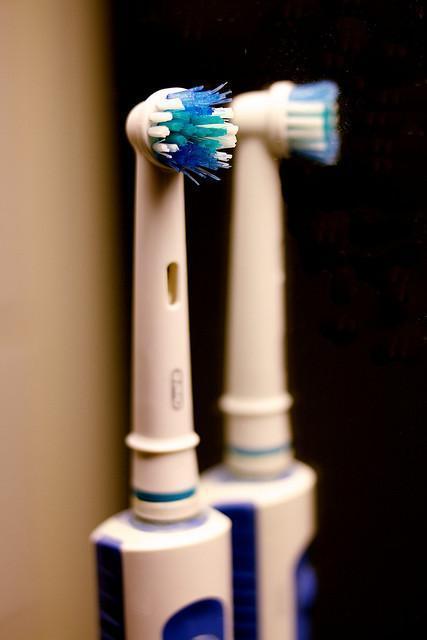How many toothbrushes can be seen?
Give a very brief answer. 2. How many people are looking at the white car?
Give a very brief answer. 0. 